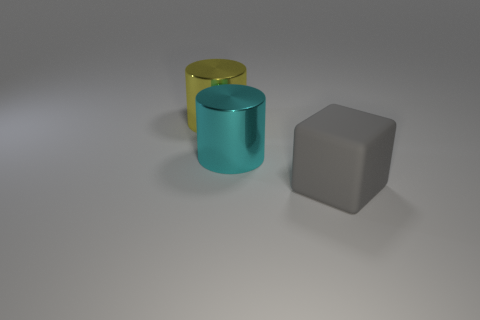What color is the object behind the big metallic object that is to the right of the yellow metal object?
Provide a succinct answer. Yellow. Does the large cyan object have the same material as the large cylinder that is behind the big cyan shiny cylinder?
Give a very brief answer. Yes. There is a cylinder on the right side of the yellow cylinder; what material is it?
Give a very brief answer. Metal. Is the number of things in front of the gray cube the same as the number of big cyan metal cylinders?
Provide a short and direct response. No. Is there any other thing that is the same size as the yellow cylinder?
Your response must be concise. Yes. What is the material of the large cylinder that is on the left side of the shiny object in front of the large yellow metal cylinder?
Offer a very short reply. Metal. There is a big thing that is on the right side of the big yellow cylinder and left of the big rubber thing; what shape is it?
Keep it short and to the point. Cylinder. There is a cyan metal thing that is the same shape as the large yellow object; what is its size?
Offer a terse response. Large. Is the number of cylinders in front of the cyan metal cylinder less than the number of big brown things?
Provide a succinct answer. No. What size is the cylinder that is in front of the yellow cylinder?
Give a very brief answer. Large. 